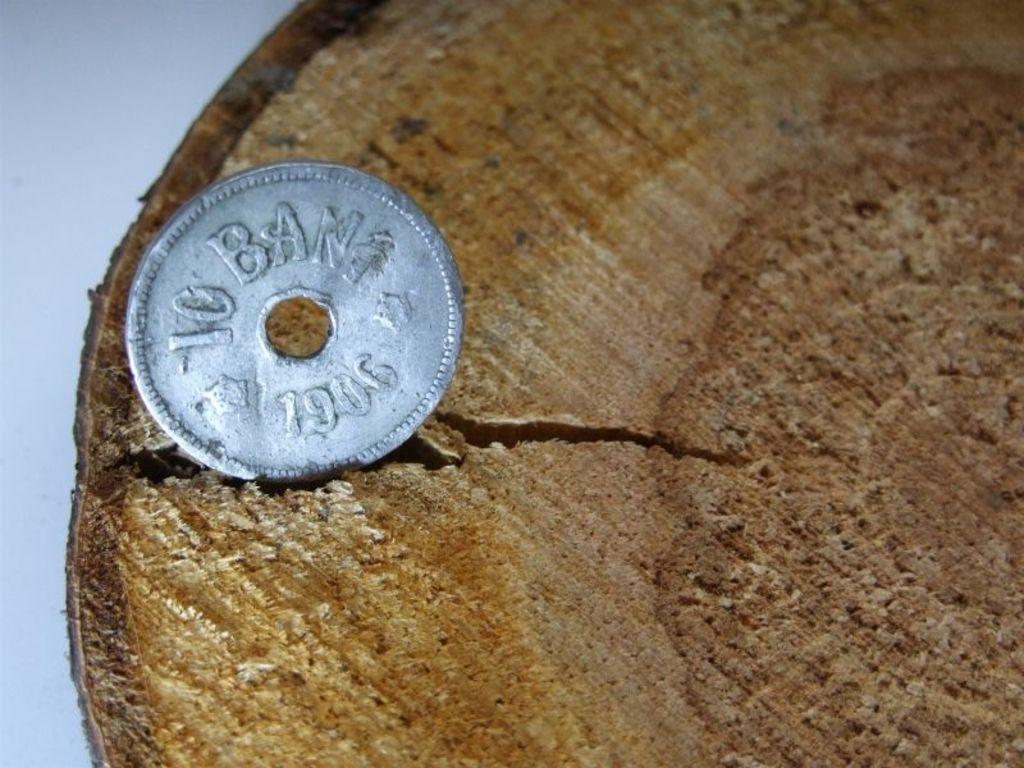<image>
Write a terse but informative summary of the picture. A coin with a hole in the center has the year 1906 on it. 